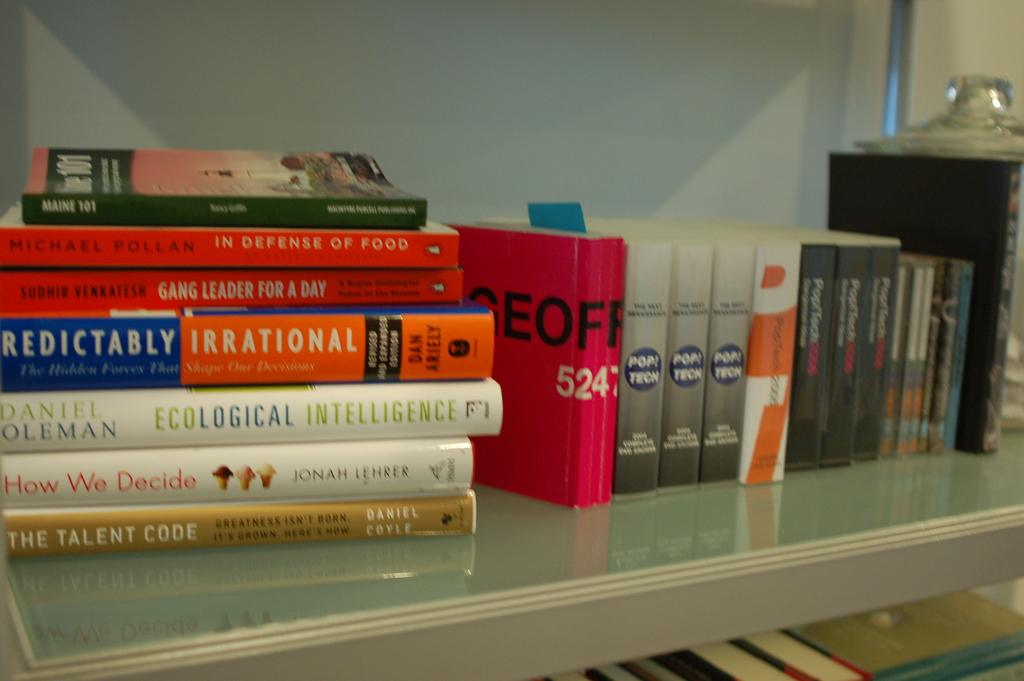<image>
Create a compact narrative representing the image presented. A lot of books are on the rack and one of them is about ecological intelligence. 